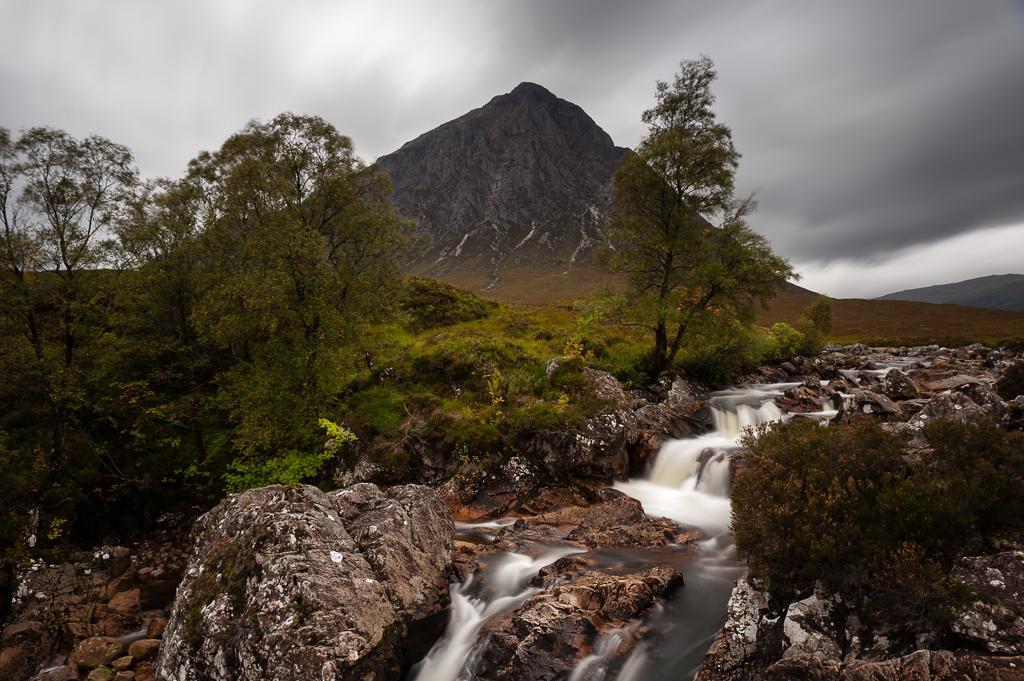Please provide a concise description of this image. In this picture we can see rocks, water, trees, mountains and in the background we can see the sky with clouds. 